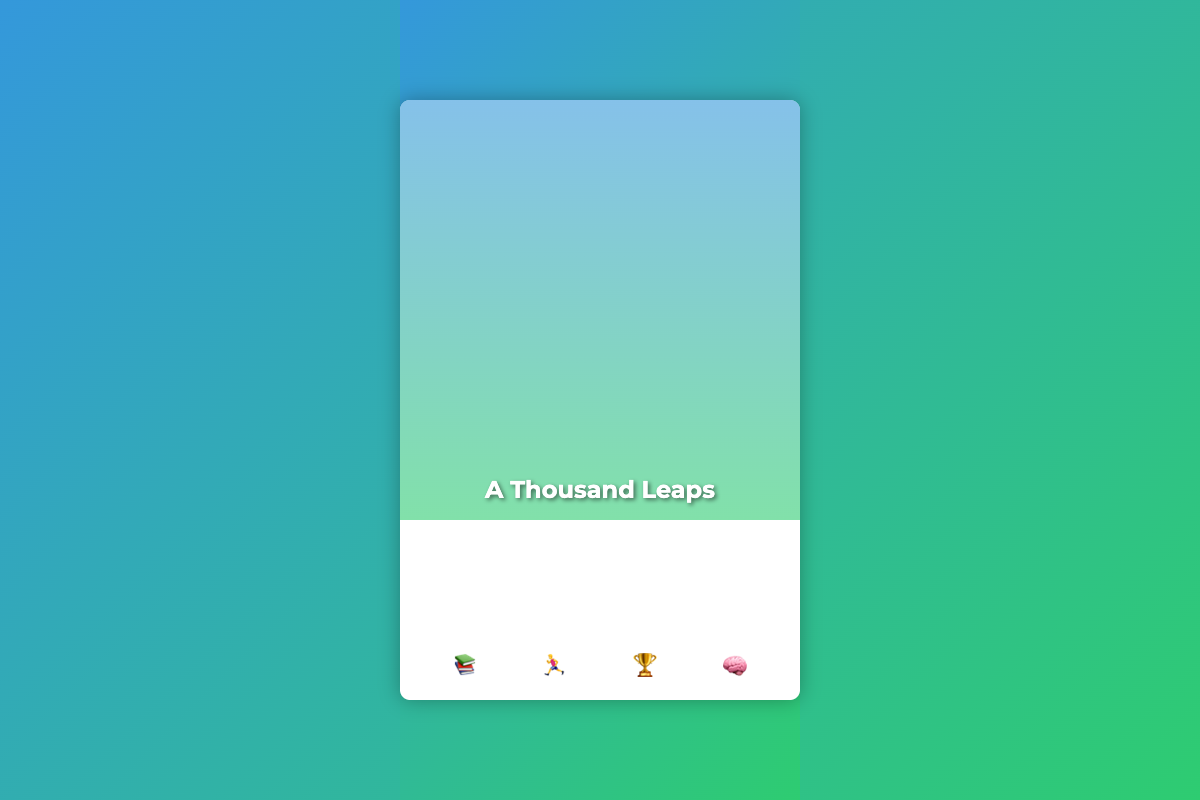What is the title of the book? The title of the book is prominently displayed on the cover image.
Answer: A Thousand Leaps What is the subtitle of the book? The subtitle provides more context about the content of the book located below the title.
Answer: Strategies for Balancing Athletic Dreams and Academic Achievements What is the primary theme depicted in the cover design? The cover design visually represents the balance between sports and academics through images of both sports equipment and study materials.
Answer: Balance How many icons are displayed at the bottom of the cover? The number of icons shown can be counted visually at the bottom of the cover design.
Answer: Four What color gradient is used in the background? The background features a specific gradient blend, which can be observed clearly in the cover design.
Answer: Blue and green What type of imagery is featured in the cover image? The imagery focuses on specific dynamic actions that represent student-athletes.
Answer: Athlete mid-jump What does the first icon represent? Each icon symbolizes elements relevant to the book’s theme; thus, the first icon suggests a particular focus.
Answer: Books What emotions does the cover convey? The overall visual elements indicate a certain emotional tone that can be inferred from the imagery and colors used.
Answer: Determination What visual design element overlaps with the cover image? An additional design feature on the cover combines elements which enhance the visual appeal and significance.
Answer: Gradient overlay 